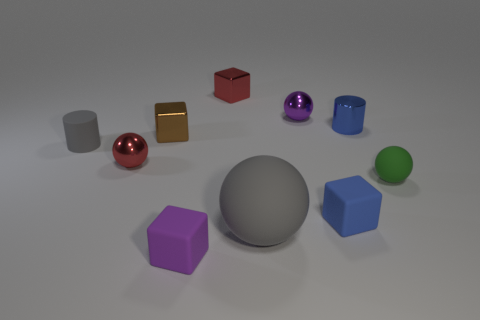How many spheres can be seen and what are their colors? There are three spheres visible in the image, with the colors red, purple, and green. 